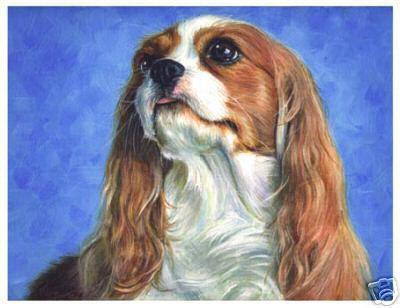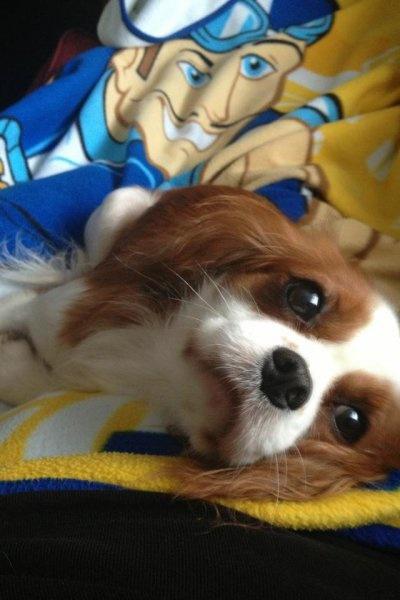The first image is the image on the left, the second image is the image on the right. Analyze the images presented: Is the assertion "Part of a human is visible in at least one of the images." valid? Answer yes or no. No. The first image is the image on the left, the second image is the image on the right. Examine the images to the left and right. Is the description "At least one image shows a spaniel on a solid blue background, and at least one image shows a spaniel gazing upward and to the left." accurate? Answer yes or no. Yes. 